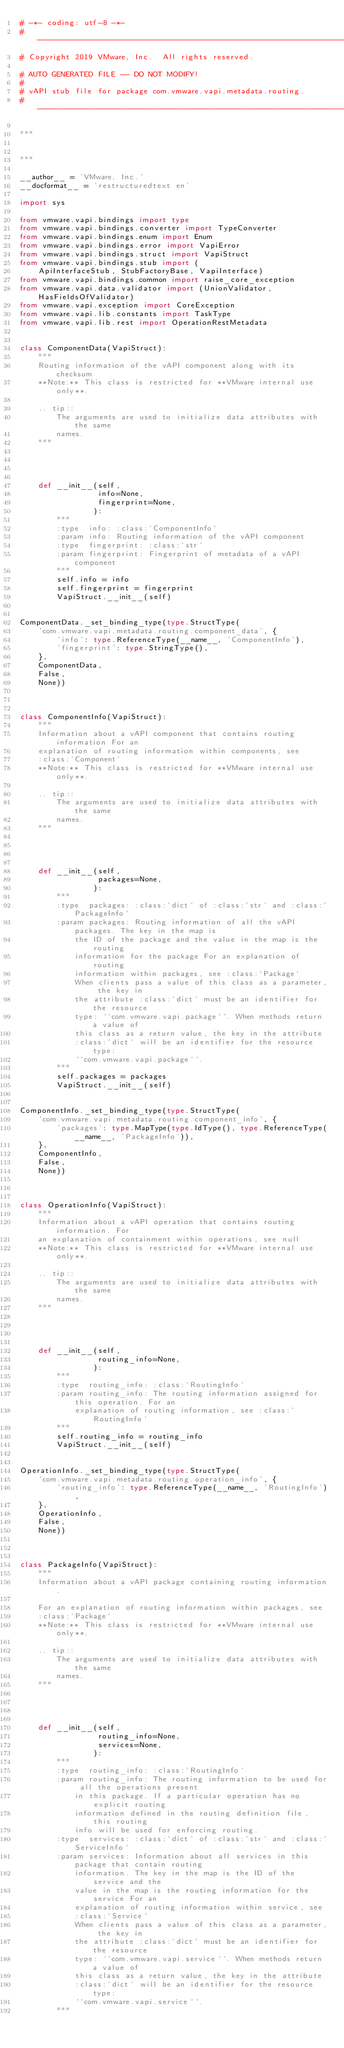<code> <loc_0><loc_0><loc_500><loc_500><_Python_># -*- coding: utf-8 -*-
#---------------------------------------------------------------------------
# Copyright 2019 VMware, Inc.  All rights reserved.

# AUTO GENERATED FILE -- DO NOT MODIFY!
#
# vAPI stub file for package com.vmware.vapi.metadata.routing.
#---------------------------------------------------------------------------

"""


"""

__author__ = 'VMware, Inc.'
__docformat__ = 'restructuredtext en'

import sys

from vmware.vapi.bindings import type
from vmware.vapi.bindings.converter import TypeConverter
from vmware.vapi.bindings.enum import Enum
from vmware.vapi.bindings.error import VapiError
from vmware.vapi.bindings.struct import VapiStruct
from vmware.vapi.bindings.stub import (
    ApiInterfaceStub, StubFactoryBase, VapiInterface)
from vmware.vapi.bindings.common import raise_core_exception
from vmware.vapi.data.validator import (UnionValidator, HasFieldsOfValidator)
from vmware.vapi.exception import CoreException
from vmware.vapi.lib.constants import TaskType
from vmware.vapi.lib.rest import OperationRestMetadata


class ComponentData(VapiStruct):
    """
    Routing information of the vAPI component along with its checksum
    **Note:** This class is restricted for **VMware internal use only**.

    .. tip::
        The arguments are used to initialize data attributes with the same
        names.
    """




    def __init__(self,
                 info=None,
                 fingerprint=None,
                ):
        """
        :type  info: :class:`ComponentInfo`
        :param info: Routing information of the vAPI component
        :type  fingerprint: :class:`str`
        :param fingerprint: Fingerprint of metadata of a vAPI component
        """
        self.info = info
        self.fingerprint = fingerprint
        VapiStruct.__init__(self)


ComponentData._set_binding_type(type.StructType(
    'com.vmware.vapi.metadata.routing.component_data', {
        'info': type.ReferenceType(__name__, 'ComponentInfo'),
        'fingerprint': type.StringType(),
    },
    ComponentData,
    False,
    None))



class ComponentInfo(VapiStruct):
    """
    Information about a vAPI component that contains routing information For an
    explanation of routing information within components, see
    :class:`Component`
    **Note:** This class is restricted for **VMware internal use only**.

    .. tip::
        The arguments are used to initialize data attributes with the same
        names.
    """




    def __init__(self,
                 packages=None,
                ):
        """
        :type  packages: :class:`dict` of :class:`str` and :class:`PackageInfo`
        :param packages: Routing information of all the vAPI packages. The key in the map is
            the ID of the package and the value in the map is the routing
            information for the package For an explanation of routing
            information within packages, see :class:`Package`
            When clients pass a value of this class as a parameter, the key in
            the attribute :class:`dict` must be an identifier for the resource
            type: ``com.vmware.vapi.package``. When methods return a value of
            this class as a return value, the key in the attribute
            :class:`dict` will be an identifier for the resource type:
            ``com.vmware.vapi.package``.
        """
        self.packages = packages
        VapiStruct.__init__(self)


ComponentInfo._set_binding_type(type.StructType(
    'com.vmware.vapi.metadata.routing.component_info', {
        'packages': type.MapType(type.IdType(), type.ReferenceType(__name__, 'PackageInfo')),
    },
    ComponentInfo,
    False,
    None))



class OperationInfo(VapiStruct):
    """
    Information about a vAPI operation that contains routing information. For
    an explanation of containment within operations, see null
    **Note:** This class is restricted for **VMware internal use only**.

    .. tip::
        The arguments are used to initialize data attributes with the same
        names.
    """




    def __init__(self,
                 routing_info=None,
                ):
        """
        :type  routing_info: :class:`RoutingInfo`
        :param routing_info: The routing information assigned for this operation. For an
            explanation of routing information, see :class:`RoutingInfo`
        """
        self.routing_info = routing_info
        VapiStruct.__init__(self)


OperationInfo._set_binding_type(type.StructType(
    'com.vmware.vapi.metadata.routing.operation_info', {
        'routing_info': type.ReferenceType(__name__, 'RoutingInfo'),
    },
    OperationInfo,
    False,
    None))



class PackageInfo(VapiStruct):
    """
    Information about a vAPI package containing routing information. 
    
    For an explanation of routing information within packages, see
    :class:`Package`
    **Note:** This class is restricted for **VMware internal use only**.

    .. tip::
        The arguments are used to initialize data attributes with the same
        names.
    """




    def __init__(self,
                 routing_info=None,
                 services=None,
                ):
        """
        :type  routing_info: :class:`RoutingInfo`
        :param routing_info: The routing information to be used for all the operations present
            in this package. If a particular operation has no explicit routing
            information defined in the routing definition file, this routing
            info will be used for enforcing routing.
        :type  services: :class:`dict` of :class:`str` and :class:`ServiceInfo`
        :param services: Information about all services in this package that contain routing
            information. The key in the map is the ID of the service and the
            value in the map is the routing information for the service For an
            explanation of routing information within service, see
            :class:`Service`
            When clients pass a value of this class as a parameter, the key in
            the attribute :class:`dict` must be an identifier for the resource
            type: ``com.vmware.vapi.service``. When methods return a value of
            this class as a return value, the key in the attribute
            :class:`dict` will be an identifier for the resource type:
            ``com.vmware.vapi.service``.
        """</code> 